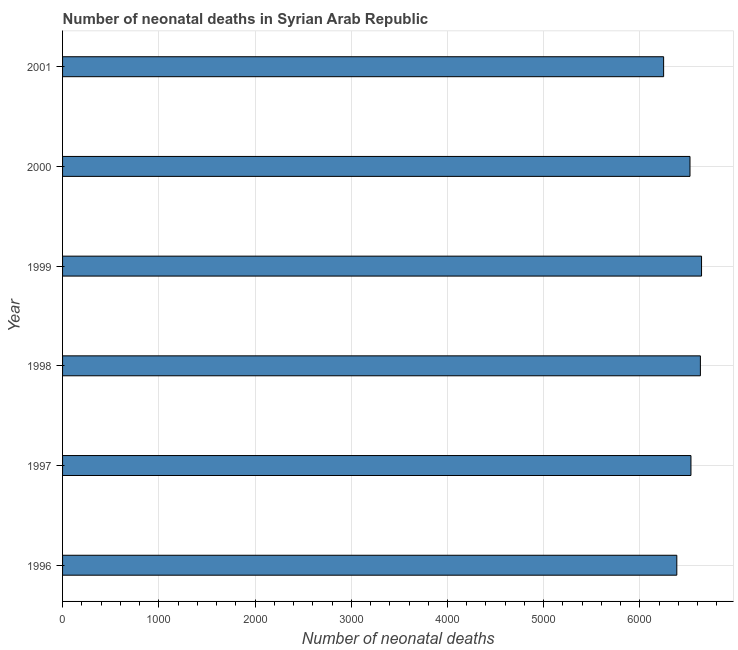Does the graph contain any zero values?
Make the answer very short. No. What is the title of the graph?
Give a very brief answer. Number of neonatal deaths in Syrian Arab Republic. What is the label or title of the X-axis?
Your answer should be compact. Number of neonatal deaths. What is the label or title of the Y-axis?
Your answer should be very brief. Year. What is the number of neonatal deaths in 1996?
Your answer should be very brief. 6383. Across all years, what is the maximum number of neonatal deaths?
Your response must be concise. 6640. Across all years, what is the minimum number of neonatal deaths?
Provide a succinct answer. 6246. What is the sum of the number of neonatal deaths?
Keep it short and to the point. 3.89e+04. What is the difference between the number of neonatal deaths in 1999 and 2001?
Offer a very short reply. 394. What is the average number of neonatal deaths per year?
Give a very brief answer. 6491. What is the median number of neonatal deaths?
Give a very brief answer. 6525. Is the difference between the number of neonatal deaths in 1999 and 2000 greater than the difference between any two years?
Ensure brevity in your answer.  No. What is the difference between the highest and the second highest number of neonatal deaths?
Keep it short and to the point. 12. Is the sum of the number of neonatal deaths in 1999 and 2000 greater than the maximum number of neonatal deaths across all years?
Offer a terse response. Yes. What is the difference between the highest and the lowest number of neonatal deaths?
Your response must be concise. 394. How many bars are there?
Ensure brevity in your answer.  6. What is the Number of neonatal deaths in 1996?
Give a very brief answer. 6383. What is the Number of neonatal deaths in 1997?
Your answer should be very brief. 6530. What is the Number of neonatal deaths in 1998?
Provide a succinct answer. 6628. What is the Number of neonatal deaths in 1999?
Give a very brief answer. 6640. What is the Number of neonatal deaths of 2000?
Keep it short and to the point. 6520. What is the Number of neonatal deaths of 2001?
Make the answer very short. 6246. What is the difference between the Number of neonatal deaths in 1996 and 1997?
Your response must be concise. -147. What is the difference between the Number of neonatal deaths in 1996 and 1998?
Ensure brevity in your answer.  -245. What is the difference between the Number of neonatal deaths in 1996 and 1999?
Your response must be concise. -257. What is the difference between the Number of neonatal deaths in 1996 and 2000?
Your answer should be very brief. -137. What is the difference between the Number of neonatal deaths in 1996 and 2001?
Give a very brief answer. 137. What is the difference between the Number of neonatal deaths in 1997 and 1998?
Provide a succinct answer. -98. What is the difference between the Number of neonatal deaths in 1997 and 1999?
Provide a short and direct response. -110. What is the difference between the Number of neonatal deaths in 1997 and 2000?
Your answer should be compact. 10. What is the difference between the Number of neonatal deaths in 1997 and 2001?
Your answer should be very brief. 284. What is the difference between the Number of neonatal deaths in 1998 and 1999?
Offer a very short reply. -12. What is the difference between the Number of neonatal deaths in 1998 and 2000?
Offer a very short reply. 108. What is the difference between the Number of neonatal deaths in 1998 and 2001?
Provide a succinct answer. 382. What is the difference between the Number of neonatal deaths in 1999 and 2000?
Provide a short and direct response. 120. What is the difference between the Number of neonatal deaths in 1999 and 2001?
Ensure brevity in your answer.  394. What is the difference between the Number of neonatal deaths in 2000 and 2001?
Give a very brief answer. 274. What is the ratio of the Number of neonatal deaths in 1996 to that in 1997?
Your answer should be compact. 0.98. What is the ratio of the Number of neonatal deaths in 1996 to that in 1999?
Keep it short and to the point. 0.96. What is the ratio of the Number of neonatal deaths in 1996 to that in 2001?
Provide a short and direct response. 1.02. What is the ratio of the Number of neonatal deaths in 1997 to that in 1998?
Provide a succinct answer. 0.98. What is the ratio of the Number of neonatal deaths in 1997 to that in 2001?
Your response must be concise. 1.04. What is the ratio of the Number of neonatal deaths in 1998 to that in 1999?
Ensure brevity in your answer.  1. What is the ratio of the Number of neonatal deaths in 1998 to that in 2000?
Ensure brevity in your answer.  1.02. What is the ratio of the Number of neonatal deaths in 1998 to that in 2001?
Your answer should be compact. 1.06. What is the ratio of the Number of neonatal deaths in 1999 to that in 2001?
Your answer should be very brief. 1.06. What is the ratio of the Number of neonatal deaths in 2000 to that in 2001?
Provide a succinct answer. 1.04. 